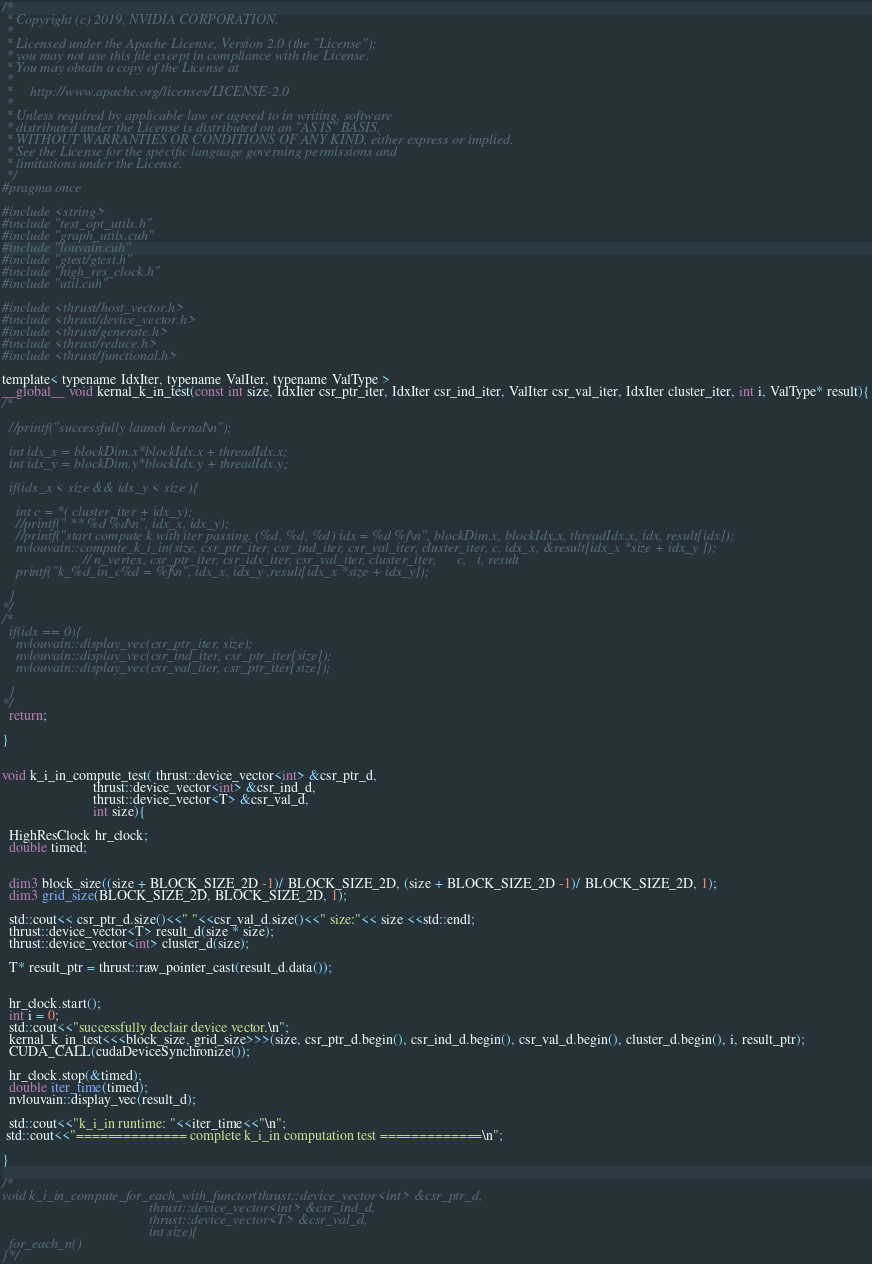<code> <loc_0><loc_0><loc_500><loc_500><_Cuda_>
/*
 * Copyright (c) 2019, NVIDIA CORPORATION.
 *
 * Licensed under the Apache License, Version 2.0 (the "License");
 * you may not use this file except in compliance with the License.
 * You may obtain a copy of the License at
 *
 *     http://www.apache.org/licenses/LICENSE-2.0
 *
 * Unless required by applicable law or agreed to in writing, software
 * distributed under the License is distributed on an "AS IS" BASIS,
 * WITHOUT WARRANTIES OR CONDITIONS OF ANY KIND, either express or implied.
 * See the License for the specific language governing permissions and
 * limitations under the License.
 */
#pragma once

#include <string>
#include "test_opt_utils.h"
#include "graph_utils.cuh"
#include "louvain.cuh"
#include "gtest/gtest.h"
#include "high_res_clock.h"
#include "util.cuh"

#include <thrust/host_vector.h>
#include <thrust/device_vector.h>
#include <thrust/generate.h>
#include <thrust/reduce.h>
#include <thrust/functional.h>

template< typename IdxIter, typename ValIter, typename ValType >
__global__ void kernal_k_in_test(const int size, IdxIter csr_ptr_iter, IdxIter csr_ind_iter, ValIter csr_val_iter, IdxIter cluster_iter, int i, ValType* result){
/*
  
  //printf("successfully launch kernal\n");

  int idx_x = blockDim.x*blockIdx.x + threadIdx.x;
  int idx_y = blockDim.y*blockIdx.y + threadIdx.y;

  if(idx_x < size && idx_y < size ){
    
    int c = *( cluster_iter + idx_y);  
    //printf(" ** %d %d\n", idx_x, idx_y); 
    //printf("start compute k with iter passing. (%d, %d, %d) idx = %d %f\n", blockDim.x, blockIdx.x, threadIdx.x, idx, result[idx]);
    nvlouvain::compute_k_i_in(size, csr_ptr_iter, csr_ind_iter, csr_val_iter, cluster_iter, c, idx_x, &result[idx_x *size + idx_y ]);
                       // n_vertex, csr_ptr_iter, csr_idx_iter, csr_val_iter, cluster_iter,      c,   i, result
    printf("k_%d_in_c%d = %f\n", idx_x, idx_y ,result[idx_x *size + idx_y]);
    
  }
*/
/*
  if(idx == 0){
    nvlouvain::display_vec(csr_ptr_iter, size);  
    nvlouvain::display_vec(csr_ind_iter, csr_ptr_iter[size]);
    nvlouvain::display_vec(csr_val_iter, csr_ptr_iter[size]);

  }
*/
  return;

}


void k_i_in_compute_test( thrust::device_vector<int> &csr_ptr_d,
                          thrust::device_vector<int> &csr_ind_d,
                          thrust::device_vector<T> &csr_val_d,
                          int size){

  HighResClock hr_clock;
  double timed;

  
  dim3 block_size((size + BLOCK_SIZE_2D -1)/ BLOCK_SIZE_2D, (size + BLOCK_SIZE_2D -1)/ BLOCK_SIZE_2D, 1);
  dim3 grid_size(BLOCK_SIZE_2D, BLOCK_SIZE_2D, 1);

  std::cout<< csr_ptr_d.size()<<" "<<csr_val_d.size()<<" size:"<< size <<std::endl;
  thrust::device_vector<T> result_d(size * size);
  thrust::device_vector<int> cluster_d(size);

  T* result_ptr = thrust::raw_pointer_cast(result_d.data());


  hr_clock.start();
  int i = 0; 
  std::cout<<"successfully declair device vector.\n";
  kernal_k_in_test<<<block_size, grid_size>>>(size, csr_ptr_d.begin(), csr_ind_d.begin(), csr_val_d.begin(), cluster_d.begin(), i, result_ptr);
  CUDA_CALL(cudaDeviceSynchronize());

  hr_clock.stop(&timed);
  double iter_time(timed);
  nvlouvain::display_vec(result_d);

  std::cout<<"k_i_in runtime: "<<iter_time<<"\n";
 std::cout<<"============== complete k_i_in computation test =============\n";
 
}

/*
void k_i_in_compute_for_each_with_functor(thrust::device_vector<int> &csr_ptr_d,
                                          thrust::device_vector<int> &csr_ind_d,
                                          thrust::device_vector<T> &csr_val_d,
                                          int size){
  for_each_n() 
}*/
</code> 